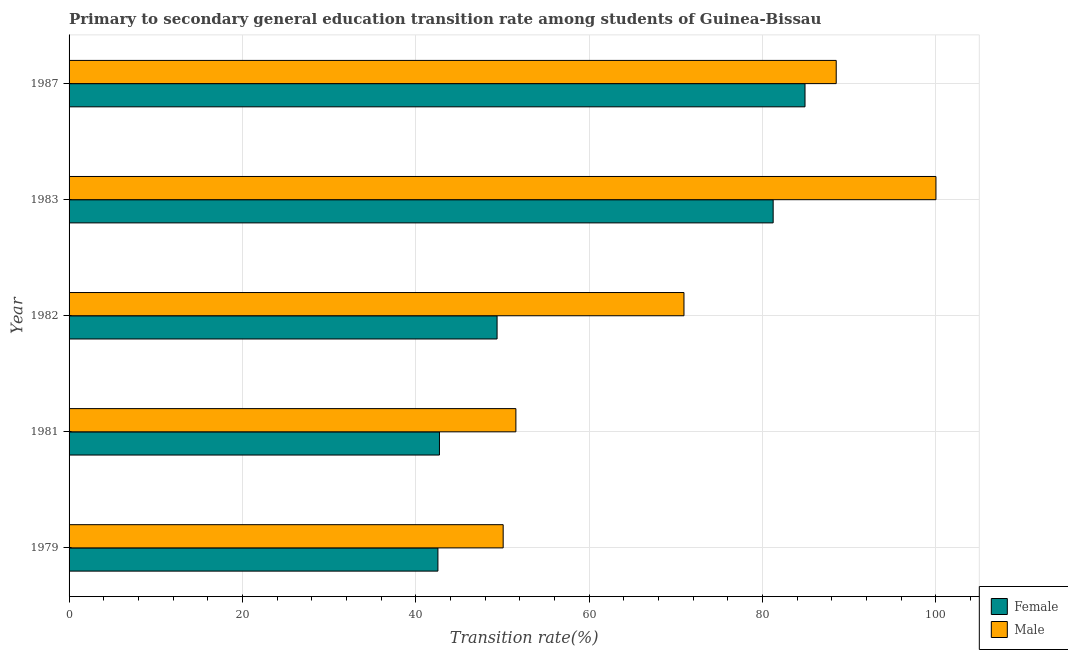How many different coloured bars are there?
Your answer should be very brief. 2. How many groups of bars are there?
Your answer should be compact. 5. Are the number of bars per tick equal to the number of legend labels?
Make the answer very short. Yes. How many bars are there on the 2nd tick from the top?
Provide a short and direct response. 2. In how many cases, is the number of bars for a given year not equal to the number of legend labels?
Offer a terse response. 0. What is the transition rate among female students in 1987?
Provide a succinct answer. 84.89. Across all years, what is the maximum transition rate among male students?
Give a very brief answer. 100. Across all years, what is the minimum transition rate among female students?
Provide a succinct answer. 42.55. In which year was the transition rate among male students minimum?
Offer a very short reply. 1979. What is the total transition rate among male students in the graph?
Offer a terse response. 361.05. What is the difference between the transition rate among female students in 1979 and that in 1987?
Give a very brief answer. -42.34. What is the difference between the transition rate among female students in 1981 and the transition rate among male students in 1982?
Your answer should be very brief. -28.21. What is the average transition rate among male students per year?
Your answer should be compact. 72.21. In the year 1981, what is the difference between the transition rate among male students and transition rate among female students?
Your answer should be very brief. 8.82. In how many years, is the transition rate among male students greater than 80 %?
Give a very brief answer. 2. What is the ratio of the transition rate among male students in 1981 to that in 1982?
Your answer should be compact. 0.73. Is the difference between the transition rate among male students in 1981 and 1983 greater than the difference between the transition rate among female students in 1981 and 1983?
Keep it short and to the point. No. What is the difference between the highest and the second highest transition rate among male students?
Provide a succinct answer. 11.51. What is the difference between the highest and the lowest transition rate among male students?
Your answer should be very brief. 49.92. In how many years, is the transition rate among male students greater than the average transition rate among male students taken over all years?
Offer a very short reply. 2. Is the sum of the transition rate among male students in 1981 and 1982 greater than the maximum transition rate among female students across all years?
Your response must be concise. Yes. What does the 2nd bar from the top in 1983 represents?
Provide a succinct answer. Female. Are all the bars in the graph horizontal?
Ensure brevity in your answer.  Yes. How many legend labels are there?
Your answer should be very brief. 2. What is the title of the graph?
Ensure brevity in your answer.  Primary to secondary general education transition rate among students of Guinea-Bissau. Does "Savings" appear as one of the legend labels in the graph?
Your answer should be compact. No. What is the label or title of the X-axis?
Make the answer very short. Transition rate(%). What is the Transition rate(%) of Female in 1979?
Give a very brief answer. 42.55. What is the Transition rate(%) in Male in 1979?
Offer a very short reply. 50.08. What is the Transition rate(%) in Female in 1981?
Make the answer very short. 42.73. What is the Transition rate(%) of Male in 1981?
Offer a terse response. 51.54. What is the Transition rate(%) of Female in 1982?
Keep it short and to the point. 49.37. What is the Transition rate(%) of Male in 1982?
Make the answer very short. 70.93. What is the Transition rate(%) of Female in 1983?
Provide a short and direct response. 81.22. What is the Transition rate(%) in Female in 1987?
Ensure brevity in your answer.  84.89. What is the Transition rate(%) in Male in 1987?
Provide a short and direct response. 88.49. Across all years, what is the maximum Transition rate(%) in Female?
Provide a succinct answer. 84.89. Across all years, what is the maximum Transition rate(%) in Male?
Your answer should be compact. 100. Across all years, what is the minimum Transition rate(%) in Female?
Give a very brief answer. 42.55. Across all years, what is the minimum Transition rate(%) of Male?
Offer a very short reply. 50.08. What is the total Transition rate(%) of Female in the graph?
Your response must be concise. 300.76. What is the total Transition rate(%) in Male in the graph?
Keep it short and to the point. 361.05. What is the difference between the Transition rate(%) of Female in 1979 and that in 1981?
Make the answer very short. -0.18. What is the difference between the Transition rate(%) in Male in 1979 and that in 1981?
Give a very brief answer. -1.47. What is the difference between the Transition rate(%) in Female in 1979 and that in 1982?
Ensure brevity in your answer.  -6.82. What is the difference between the Transition rate(%) of Male in 1979 and that in 1982?
Give a very brief answer. -20.86. What is the difference between the Transition rate(%) of Female in 1979 and that in 1983?
Give a very brief answer. -38.67. What is the difference between the Transition rate(%) of Male in 1979 and that in 1983?
Give a very brief answer. -49.92. What is the difference between the Transition rate(%) of Female in 1979 and that in 1987?
Make the answer very short. -42.34. What is the difference between the Transition rate(%) in Male in 1979 and that in 1987?
Offer a very short reply. -38.42. What is the difference between the Transition rate(%) in Female in 1981 and that in 1982?
Your answer should be compact. -6.65. What is the difference between the Transition rate(%) of Male in 1981 and that in 1982?
Offer a terse response. -19.39. What is the difference between the Transition rate(%) in Female in 1981 and that in 1983?
Offer a very short reply. -38.49. What is the difference between the Transition rate(%) of Male in 1981 and that in 1983?
Offer a very short reply. -48.46. What is the difference between the Transition rate(%) of Female in 1981 and that in 1987?
Ensure brevity in your answer.  -42.17. What is the difference between the Transition rate(%) in Male in 1981 and that in 1987?
Keep it short and to the point. -36.95. What is the difference between the Transition rate(%) of Female in 1982 and that in 1983?
Offer a very short reply. -31.85. What is the difference between the Transition rate(%) in Male in 1982 and that in 1983?
Offer a terse response. -29.07. What is the difference between the Transition rate(%) in Female in 1982 and that in 1987?
Provide a succinct answer. -35.52. What is the difference between the Transition rate(%) in Male in 1982 and that in 1987?
Offer a very short reply. -17.56. What is the difference between the Transition rate(%) of Female in 1983 and that in 1987?
Your response must be concise. -3.67. What is the difference between the Transition rate(%) of Male in 1983 and that in 1987?
Your answer should be compact. 11.51. What is the difference between the Transition rate(%) of Female in 1979 and the Transition rate(%) of Male in 1981?
Make the answer very short. -8.99. What is the difference between the Transition rate(%) in Female in 1979 and the Transition rate(%) in Male in 1982?
Your answer should be compact. -28.38. What is the difference between the Transition rate(%) of Female in 1979 and the Transition rate(%) of Male in 1983?
Your response must be concise. -57.45. What is the difference between the Transition rate(%) of Female in 1979 and the Transition rate(%) of Male in 1987?
Keep it short and to the point. -45.94. What is the difference between the Transition rate(%) in Female in 1981 and the Transition rate(%) in Male in 1982?
Your answer should be compact. -28.21. What is the difference between the Transition rate(%) in Female in 1981 and the Transition rate(%) in Male in 1983?
Keep it short and to the point. -57.27. What is the difference between the Transition rate(%) in Female in 1981 and the Transition rate(%) in Male in 1987?
Offer a terse response. -45.77. What is the difference between the Transition rate(%) in Female in 1982 and the Transition rate(%) in Male in 1983?
Give a very brief answer. -50.63. What is the difference between the Transition rate(%) in Female in 1982 and the Transition rate(%) in Male in 1987?
Provide a short and direct response. -39.12. What is the difference between the Transition rate(%) in Female in 1983 and the Transition rate(%) in Male in 1987?
Make the answer very short. -7.27. What is the average Transition rate(%) of Female per year?
Give a very brief answer. 60.15. What is the average Transition rate(%) in Male per year?
Give a very brief answer. 72.21. In the year 1979, what is the difference between the Transition rate(%) in Female and Transition rate(%) in Male?
Offer a terse response. -7.53. In the year 1981, what is the difference between the Transition rate(%) of Female and Transition rate(%) of Male?
Provide a succinct answer. -8.82. In the year 1982, what is the difference between the Transition rate(%) of Female and Transition rate(%) of Male?
Ensure brevity in your answer.  -21.56. In the year 1983, what is the difference between the Transition rate(%) in Female and Transition rate(%) in Male?
Make the answer very short. -18.78. In the year 1987, what is the difference between the Transition rate(%) in Female and Transition rate(%) in Male?
Keep it short and to the point. -3.6. What is the ratio of the Transition rate(%) in Female in 1979 to that in 1981?
Offer a very short reply. 1. What is the ratio of the Transition rate(%) of Male in 1979 to that in 1981?
Give a very brief answer. 0.97. What is the ratio of the Transition rate(%) of Female in 1979 to that in 1982?
Provide a succinct answer. 0.86. What is the ratio of the Transition rate(%) of Male in 1979 to that in 1982?
Your response must be concise. 0.71. What is the ratio of the Transition rate(%) in Female in 1979 to that in 1983?
Provide a succinct answer. 0.52. What is the ratio of the Transition rate(%) of Male in 1979 to that in 1983?
Your response must be concise. 0.5. What is the ratio of the Transition rate(%) in Female in 1979 to that in 1987?
Your response must be concise. 0.5. What is the ratio of the Transition rate(%) of Male in 1979 to that in 1987?
Give a very brief answer. 0.57. What is the ratio of the Transition rate(%) of Female in 1981 to that in 1982?
Provide a succinct answer. 0.87. What is the ratio of the Transition rate(%) in Male in 1981 to that in 1982?
Ensure brevity in your answer.  0.73. What is the ratio of the Transition rate(%) in Female in 1981 to that in 1983?
Offer a very short reply. 0.53. What is the ratio of the Transition rate(%) in Male in 1981 to that in 1983?
Offer a very short reply. 0.52. What is the ratio of the Transition rate(%) of Female in 1981 to that in 1987?
Your response must be concise. 0.5. What is the ratio of the Transition rate(%) of Male in 1981 to that in 1987?
Your answer should be compact. 0.58. What is the ratio of the Transition rate(%) of Female in 1982 to that in 1983?
Provide a succinct answer. 0.61. What is the ratio of the Transition rate(%) in Male in 1982 to that in 1983?
Make the answer very short. 0.71. What is the ratio of the Transition rate(%) in Female in 1982 to that in 1987?
Offer a very short reply. 0.58. What is the ratio of the Transition rate(%) of Male in 1982 to that in 1987?
Make the answer very short. 0.8. What is the ratio of the Transition rate(%) in Female in 1983 to that in 1987?
Your response must be concise. 0.96. What is the ratio of the Transition rate(%) in Male in 1983 to that in 1987?
Make the answer very short. 1.13. What is the difference between the highest and the second highest Transition rate(%) in Female?
Provide a short and direct response. 3.67. What is the difference between the highest and the second highest Transition rate(%) in Male?
Offer a terse response. 11.51. What is the difference between the highest and the lowest Transition rate(%) in Female?
Make the answer very short. 42.34. What is the difference between the highest and the lowest Transition rate(%) of Male?
Provide a succinct answer. 49.92. 